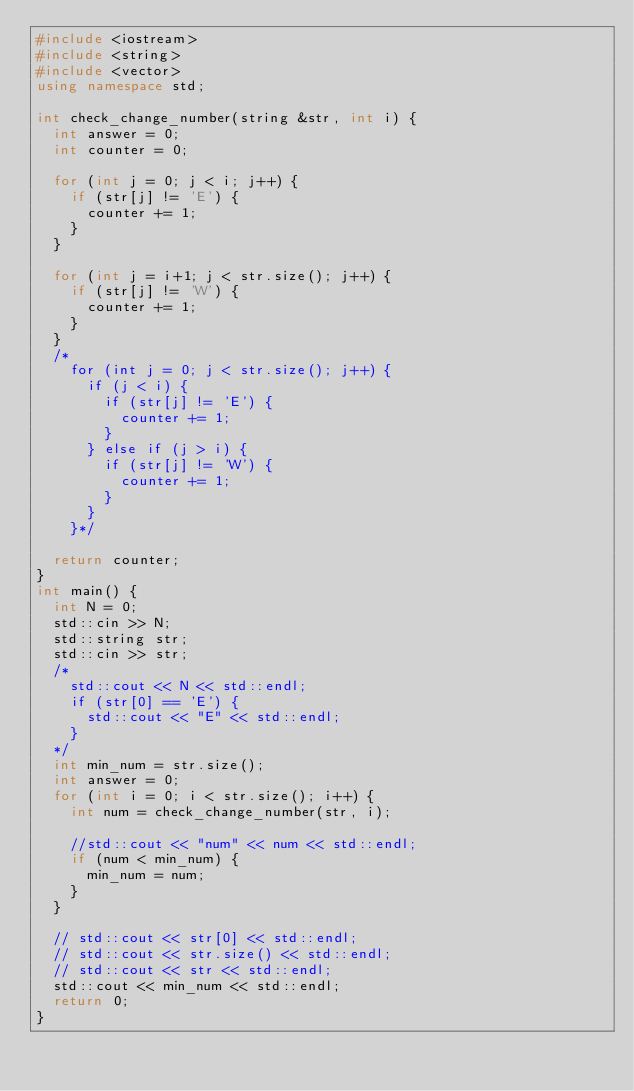Convert code to text. <code><loc_0><loc_0><loc_500><loc_500><_C++_>#include <iostream>
#include <string>
#include <vector>
using namespace std;

int check_change_number(string &str, int i) {
  int answer = 0;
  int counter = 0;

  for (int j = 0; j < i; j++) {
    if (str[j] != 'E') {
      counter += 1;
    }
  }

  for (int j = i+1; j < str.size(); j++) {
    if (str[j] != 'W') {
      counter += 1;
    }
  }
  /*
    for (int j = 0; j < str.size(); j++) {
      if (j < i) {
        if (str[j] != 'E') {
          counter += 1;
        }
      } else if (j > i) {
        if (str[j] != 'W') {
          counter += 1;
        }
      }
    }*/

  return counter;
}
int main() {
  int N = 0;
  std::cin >> N;
  std::string str;
  std::cin >> str;
  /*
    std::cout << N << std::endl;
    if (str[0] == 'E') {
      std::cout << "E" << std::endl;
    }
  */
  int min_num = str.size();
  int answer = 0;
  for (int i = 0; i < str.size(); i++) {
    int num = check_change_number(str, i);

    //std::cout << "num" << num << std::endl;
    if (num < min_num) {
      min_num = num;
    }
  }

  // std::cout << str[0] << std::endl;
  // std::cout << str.size() << std::endl;
  // std::cout << str << std::endl;
  std::cout << min_num << std::endl;
  return 0;
}</code> 